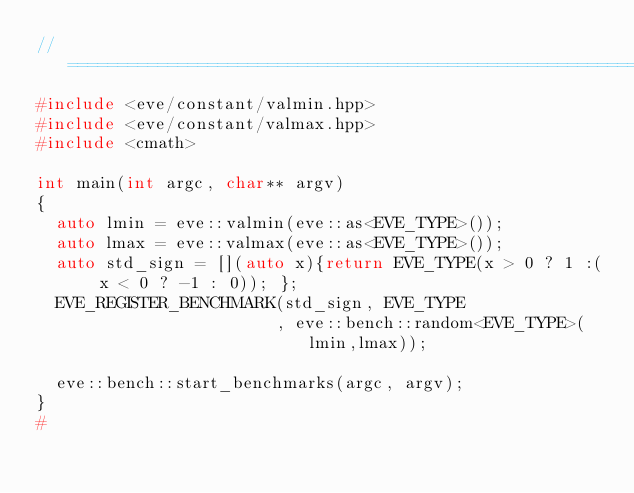Convert code to text. <code><loc_0><loc_0><loc_500><loc_500><_C++_>//==================================================================================================
#include <eve/constant/valmin.hpp>
#include <eve/constant/valmax.hpp>
#include <cmath>

int main(int argc, char** argv)
{
  auto lmin = eve::valmin(eve::as<EVE_TYPE>());
  auto lmax = eve::valmax(eve::as<EVE_TYPE>());
  auto std_sign = [](auto x){return EVE_TYPE(x > 0 ? 1 :( x < 0 ? -1 : 0)); };
  EVE_REGISTER_BENCHMARK(std_sign, EVE_TYPE
                        , eve::bench::random<EVE_TYPE>(lmin,lmax));

  eve::bench::start_benchmarks(argc, argv);
}
#
</code> 